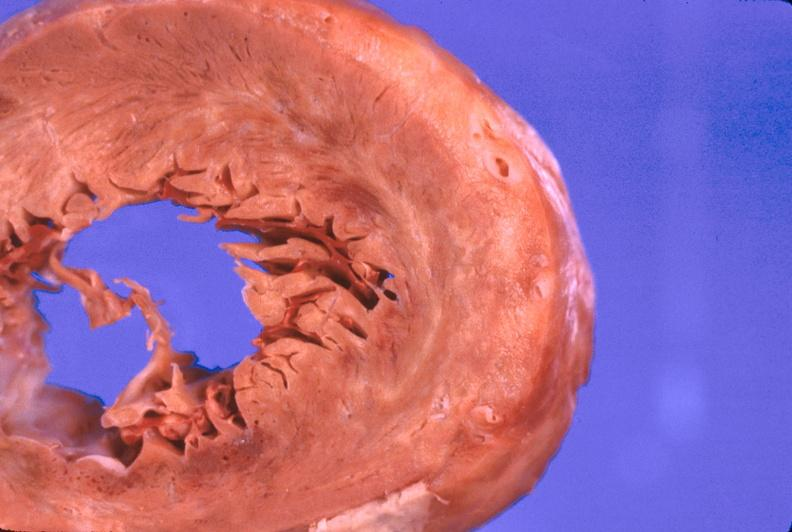what does this image show?
Answer the question using a single word or phrase. Heart 